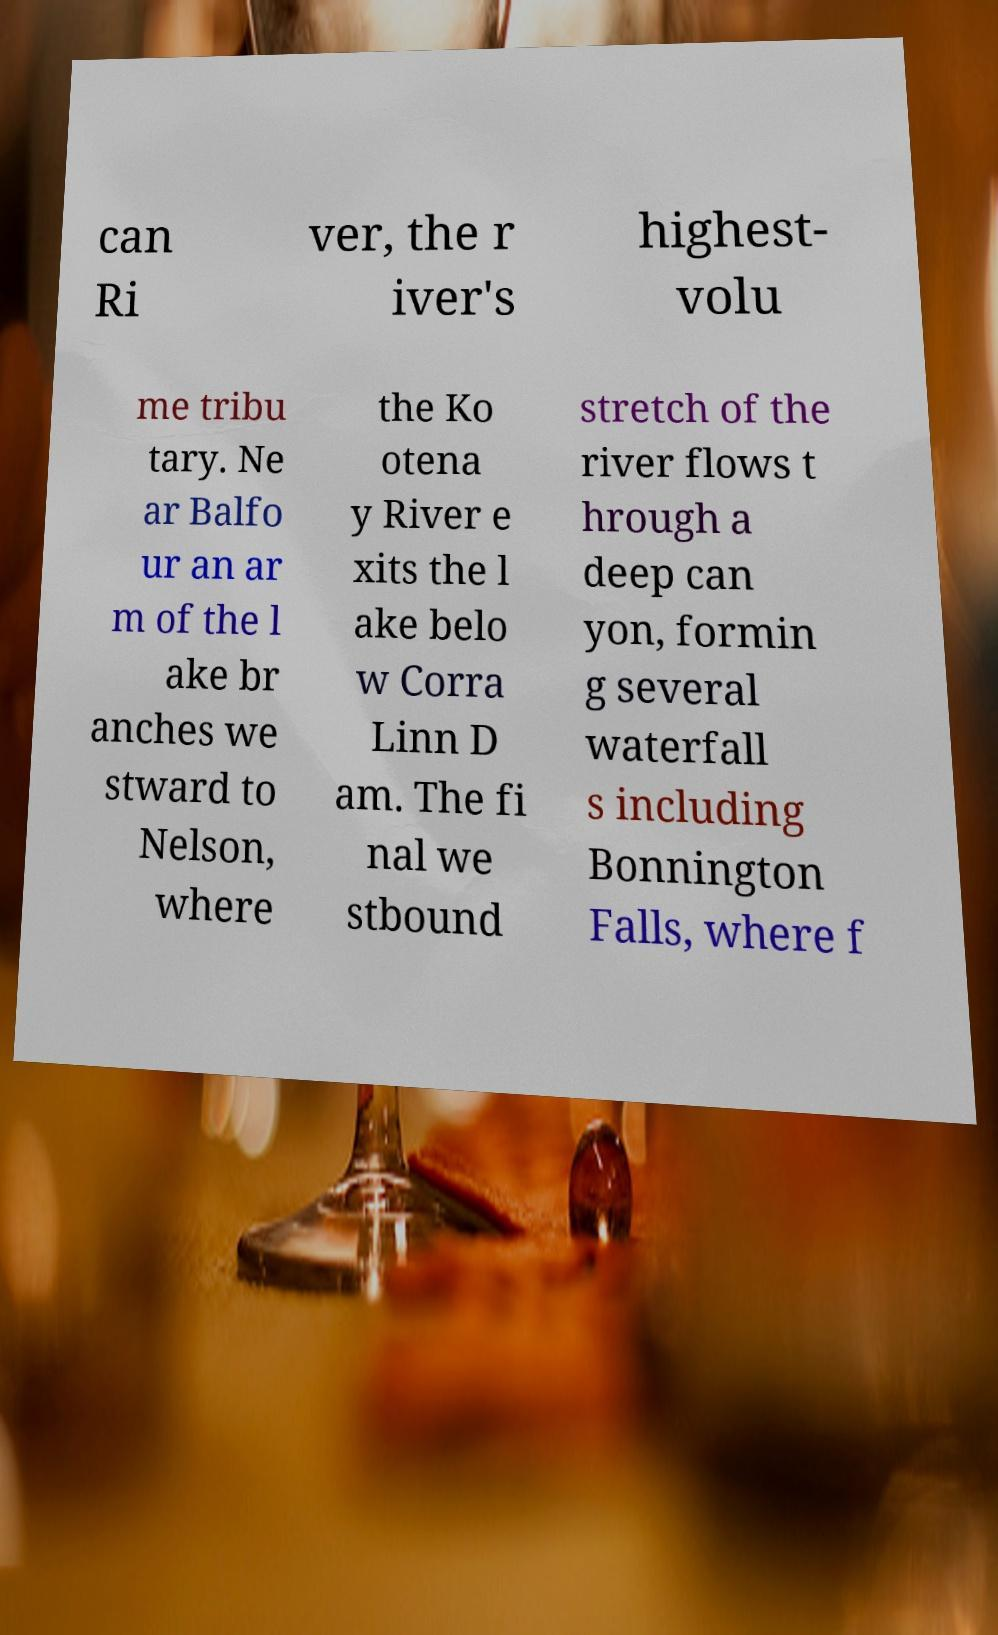For documentation purposes, I need the text within this image transcribed. Could you provide that? can Ri ver, the r iver's highest- volu me tribu tary. Ne ar Balfo ur an ar m of the l ake br anches we stward to Nelson, where the Ko otena y River e xits the l ake belo w Corra Linn D am. The fi nal we stbound stretch of the river flows t hrough a deep can yon, formin g several waterfall s including Bonnington Falls, where f 